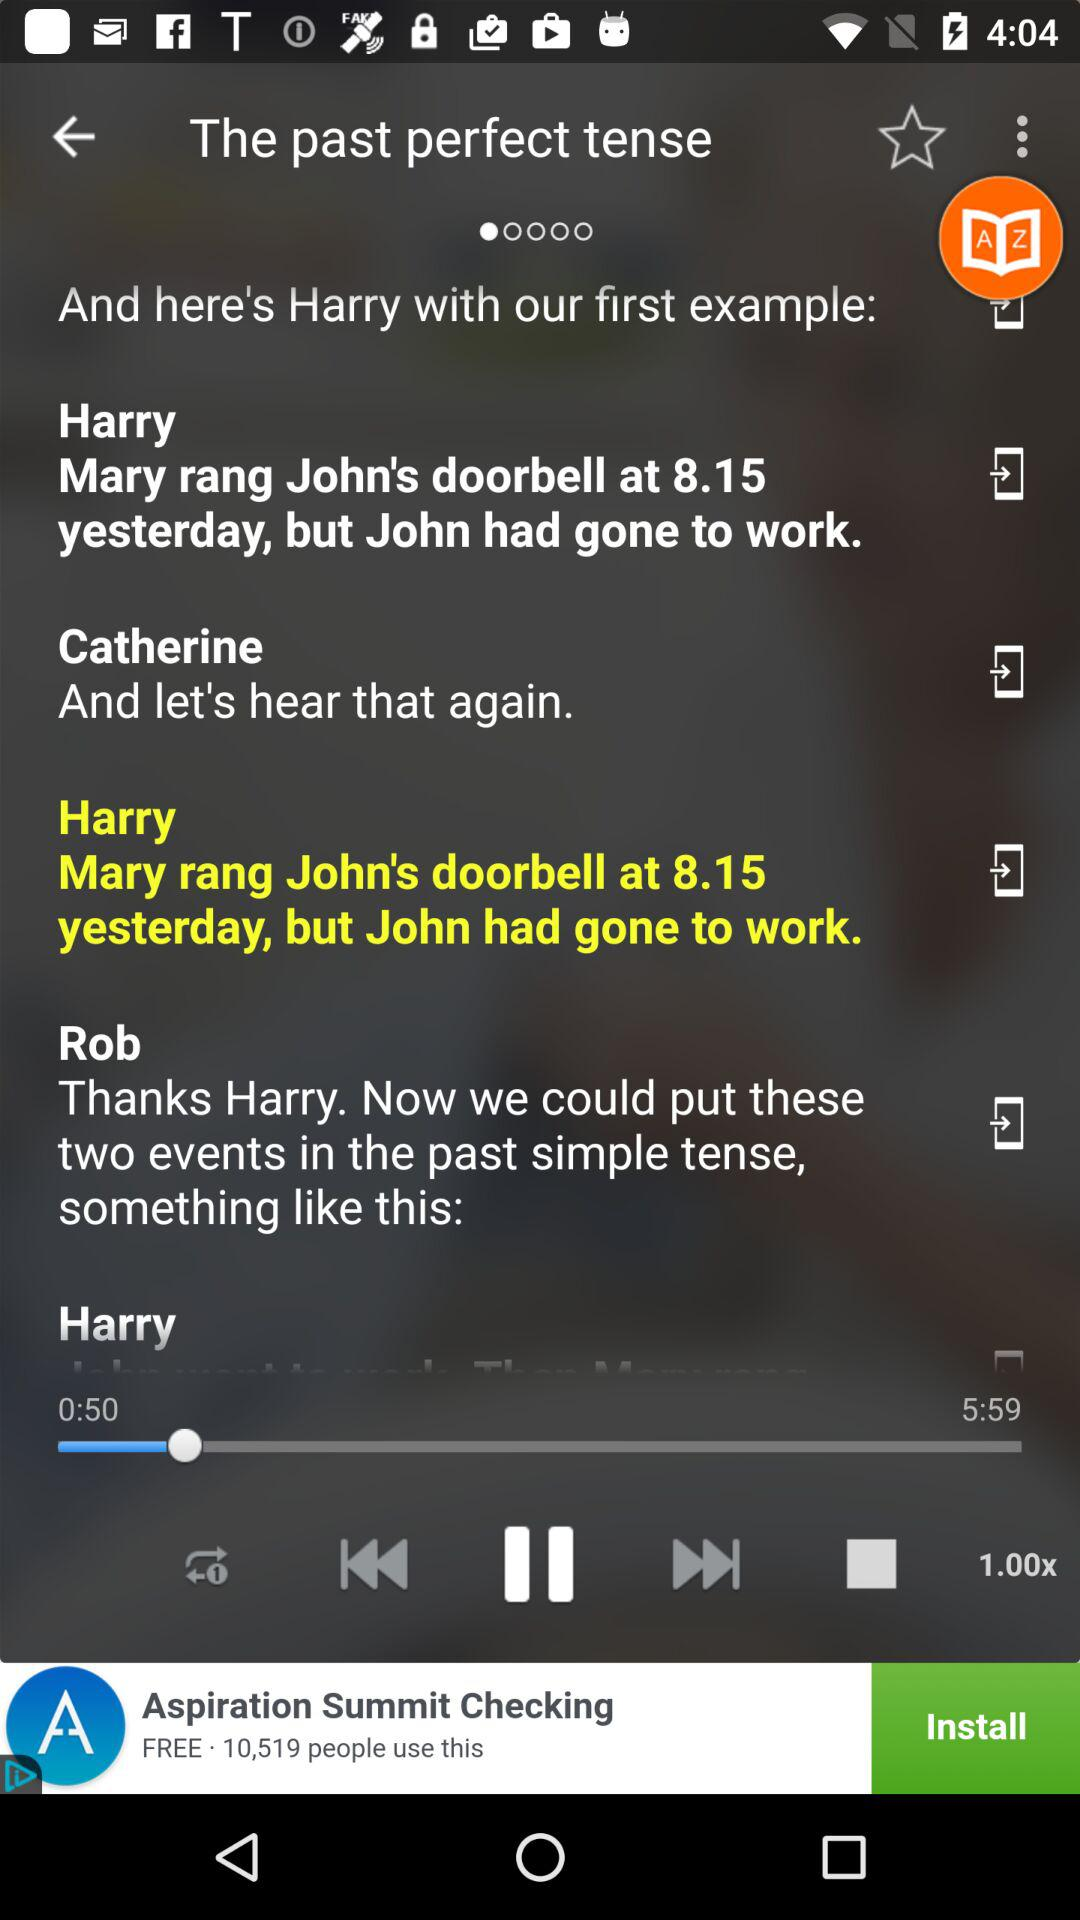How long is the song? The song is 5 minutes 59 seconds long. 